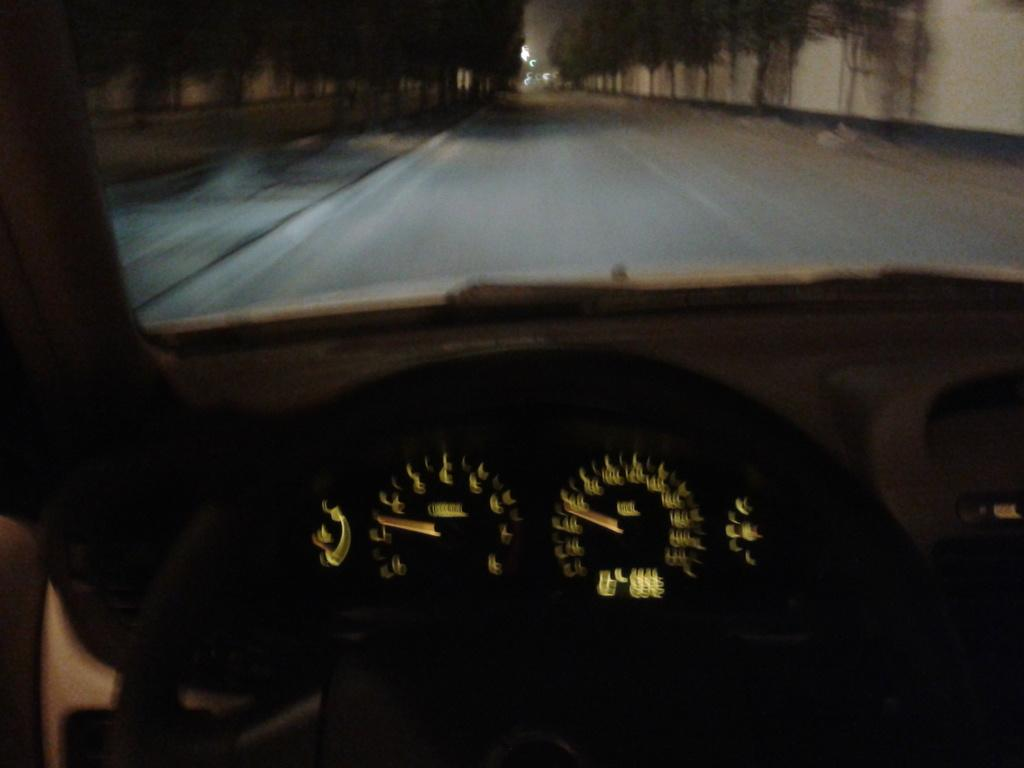What type of setting is depicted in the image? The image is an inside view of a vehicle. What can be seen outside the vehicle in the image? Trees and a road are visible in the background of the image. Are there any other objects or features visible in the background of the image? Yes, there are other unspecified objects visible in the background of the image. Can you tell me how many times the pump has been used in the image? There is no pump present in the image, so it cannot be determined how many times it has been used. 